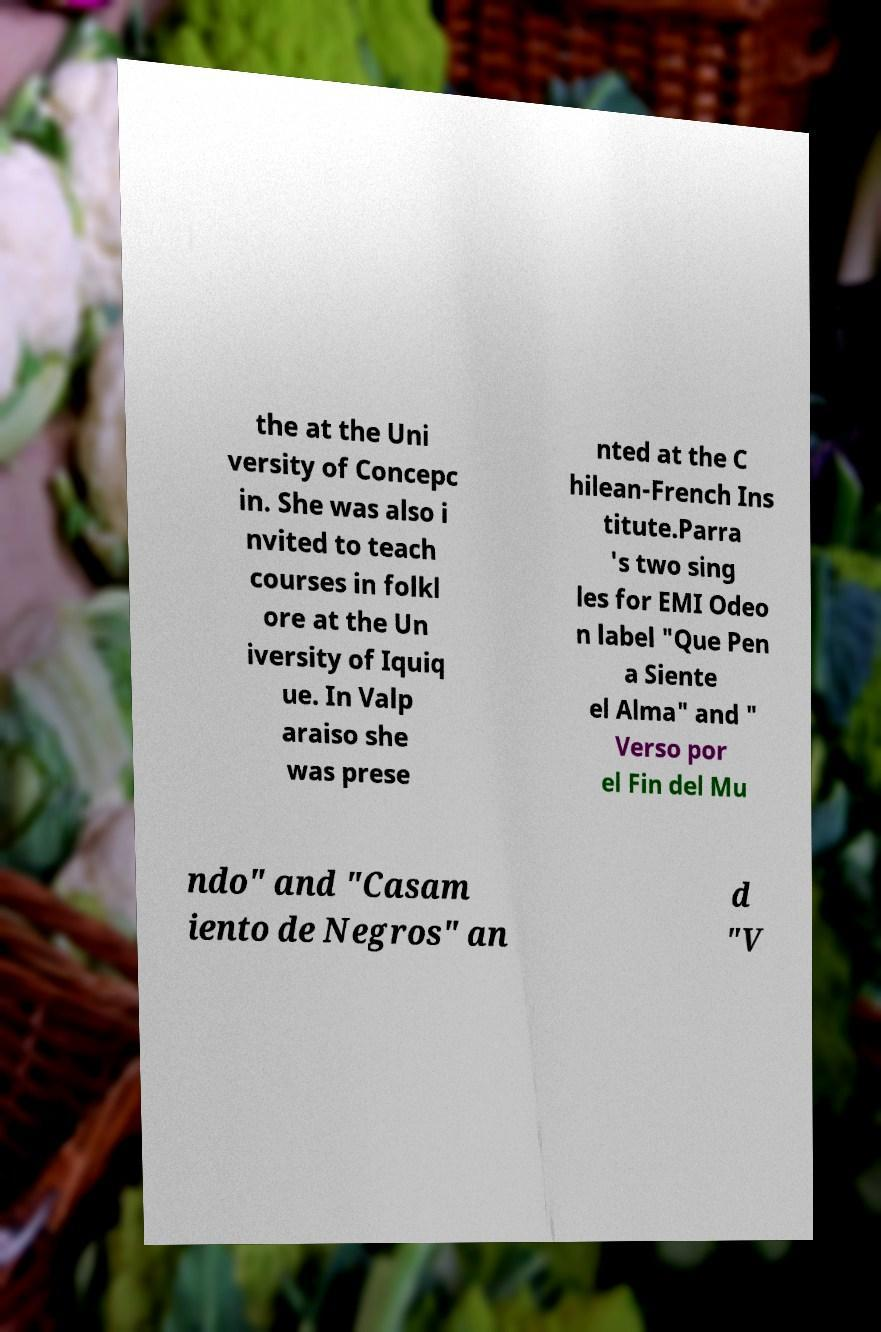There's text embedded in this image that I need extracted. Can you transcribe it verbatim? the at the Uni versity of Concepc in. She was also i nvited to teach courses in folkl ore at the Un iversity of Iquiq ue. In Valp araiso she was prese nted at the C hilean-French Ins titute.Parra 's two sing les for EMI Odeo n label "Que Pen a Siente el Alma" and " Verso por el Fin del Mu ndo" and "Casam iento de Negros" an d "V 